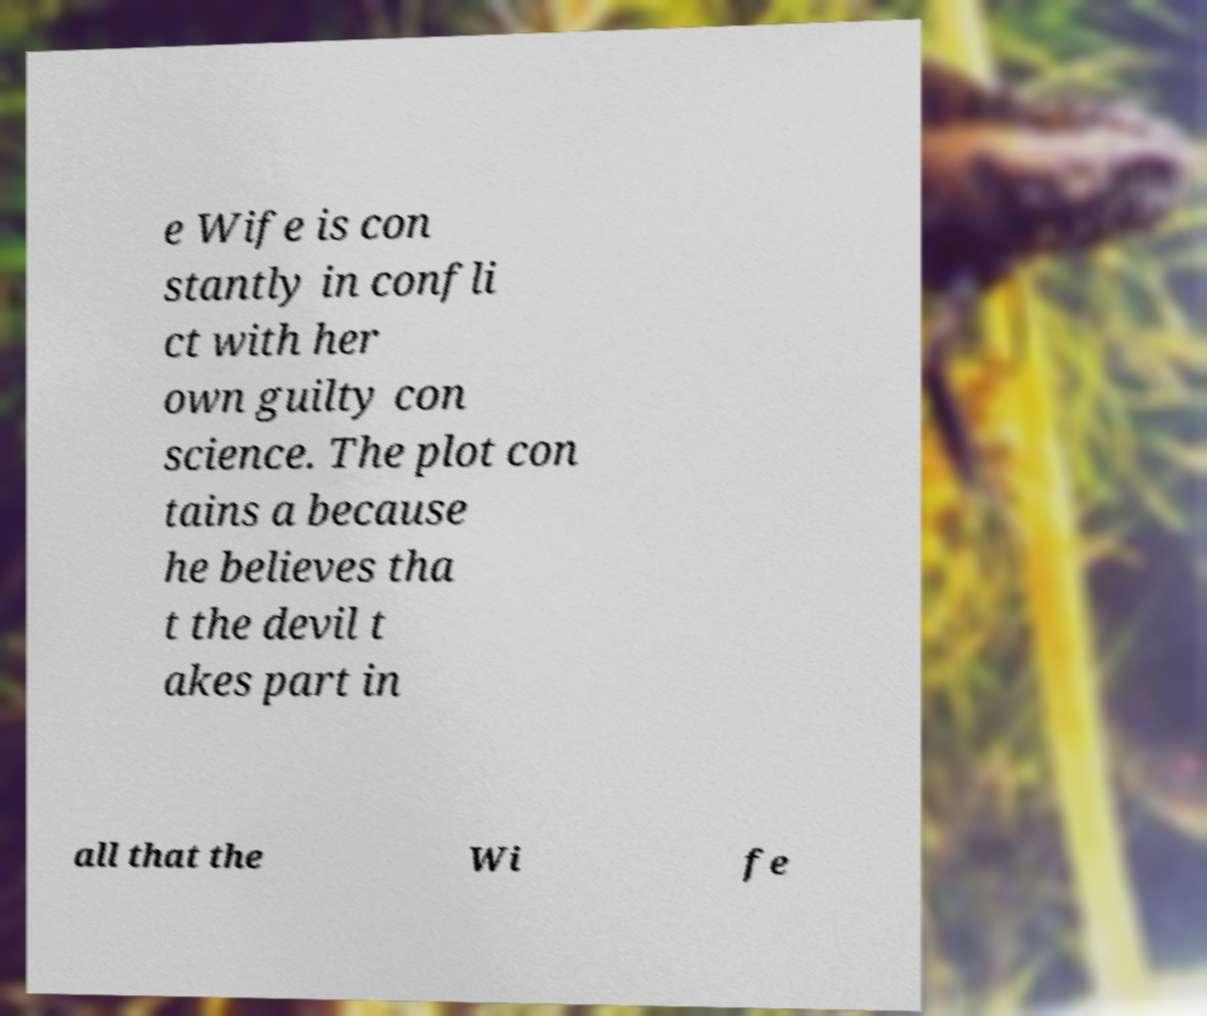For documentation purposes, I need the text within this image transcribed. Could you provide that? e Wife is con stantly in confli ct with her own guilty con science. The plot con tains a because he believes tha t the devil t akes part in all that the Wi fe 